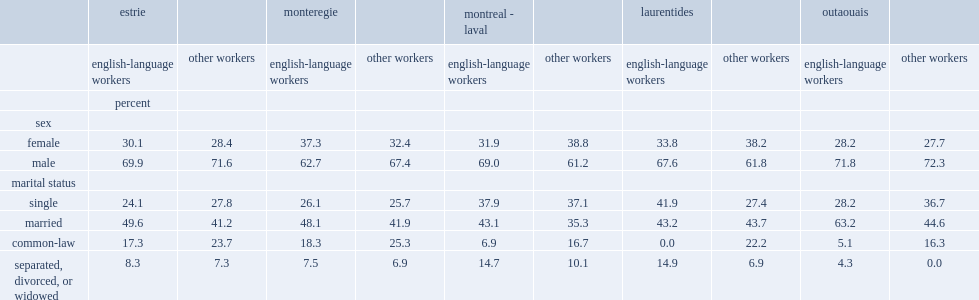In 2011, what percent of english-language agricultural workers in quebec's agricultural regions was male? 69.9 62.7 69 67.6 71.8. Which language group has more men in the montreal-laval and laurentides regions? english-language workers or other workers? English-language workers. Which language group has fewer men in the monteregie region? english-language workers or other workers? English-language workers. Which language group was more likely to be married or separated, divorced, or widowed in all five quebec agricultural regions? english-language workers or other workers? English-language workers. Which language group was less likely to be in a common-law relationship, in all five quebec agricultural regions? english-language workers or other workers? English-language workers. Which language group was less likely to be single in the estrie and outaouais agricultural regions? english-language workers or other workers? English-language workers. Which language group was more likely to be single in the laurentides region? english-language workers or other workers? English-language workers. 